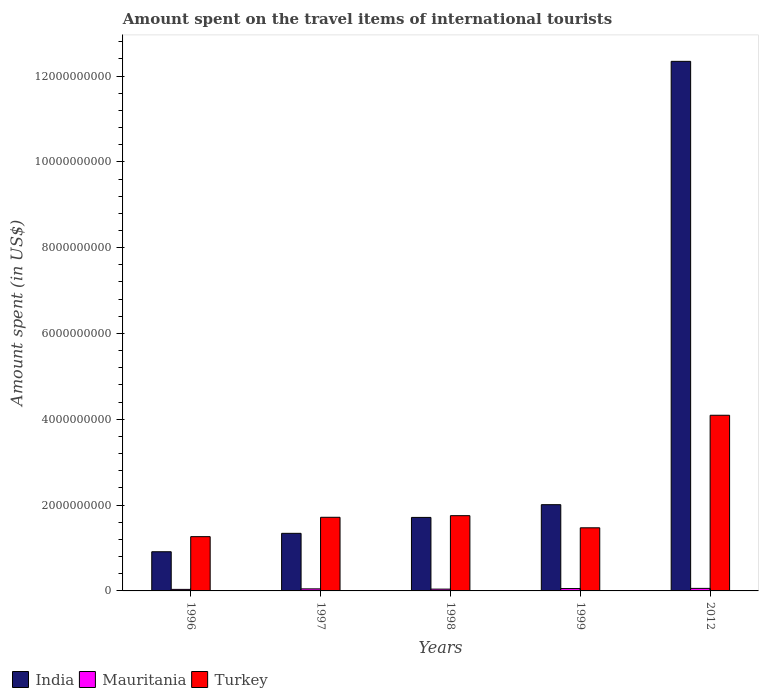How many different coloured bars are there?
Your answer should be compact. 3. Are the number of bars on each tick of the X-axis equal?
Ensure brevity in your answer.  Yes. How many bars are there on the 2nd tick from the right?
Provide a short and direct response. 3. What is the label of the 4th group of bars from the left?
Your answer should be very brief. 1999. What is the amount spent on the travel items of international tourists in India in 2012?
Offer a very short reply. 1.23e+1. Across all years, what is the maximum amount spent on the travel items of international tourists in Turkey?
Your answer should be very brief. 4.09e+09. Across all years, what is the minimum amount spent on the travel items of international tourists in India?
Make the answer very short. 9.13e+08. In which year was the amount spent on the travel items of international tourists in Turkey minimum?
Keep it short and to the point. 1996. What is the total amount spent on the travel items of international tourists in Mauritania in the graph?
Keep it short and to the point. 2.40e+08. What is the difference between the amount spent on the travel items of international tourists in Turkey in 1997 and that in 2012?
Offer a terse response. -2.38e+09. What is the difference between the amount spent on the travel items of international tourists in Mauritania in 2012 and the amount spent on the travel items of international tourists in India in 1999?
Provide a short and direct response. -1.95e+09. What is the average amount spent on the travel items of international tourists in Turkey per year?
Provide a short and direct response. 2.06e+09. In the year 1998, what is the difference between the amount spent on the travel items of international tourists in Mauritania and amount spent on the travel items of international tourists in Turkey?
Offer a very short reply. -1.71e+09. In how many years, is the amount spent on the travel items of international tourists in Turkey greater than 10800000000 US$?
Your answer should be compact. 0. What is the ratio of the amount spent on the travel items of international tourists in Mauritania in 1996 to that in 2012?
Provide a succinct answer. 0.61. What is the difference between the highest and the second highest amount spent on the travel items of international tourists in Turkey?
Keep it short and to the point. 2.34e+09. What is the difference between the highest and the lowest amount spent on the travel items of international tourists in India?
Your response must be concise. 1.14e+1. In how many years, is the amount spent on the travel items of international tourists in Mauritania greater than the average amount spent on the travel items of international tourists in Mauritania taken over all years?
Offer a terse response. 2. Is the sum of the amount spent on the travel items of international tourists in Mauritania in 1996 and 2012 greater than the maximum amount spent on the travel items of international tourists in India across all years?
Your answer should be very brief. No. What does the 2nd bar from the right in 1999 represents?
Ensure brevity in your answer.  Mauritania. How many bars are there?
Your answer should be very brief. 15. Are all the bars in the graph horizontal?
Make the answer very short. No. Are the values on the major ticks of Y-axis written in scientific E-notation?
Your answer should be very brief. No. Does the graph contain any zero values?
Your answer should be very brief. No. Where does the legend appear in the graph?
Provide a succinct answer. Bottom left. How many legend labels are there?
Your answer should be compact. 3. What is the title of the graph?
Your response must be concise. Amount spent on the travel items of international tourists. Does "Small states" appear as one of the legend labels in the graph?
Offer a terse response. No. What is the label or title of the Y-axis?
Your answer should be compact. Amount spent (in US$). What is the Amount spent (in US$) of India in 1996?
Give a very brief answer. 9.13e+08. What is the Amount spent (in US$) of Mauritania in 1996?
Provide a succinct answer. 3.60e+07. What is the Amount spent (in US$) in Turkey in 1996?
Give a very brief answer. 1.26e+09. What is the Amount spent (in US$) in India in 1997?
Make the answer very short. 1.34e+09. What is the Amount spent (in US$) of Mauritania in 1997?
Give a very brief answer. 4.80e+07. What is the Amount spent (in US$) of Turkey in 1997?
Keep it short and to the point. 1.72e+09. What is the Amount spent (in US$) in India in 1998?
Keep it short and to the point. 1.71e+09. What is the Amount spent (in US$) in Mauritania in 1998?
Your answer should be compact. 4.20e+07. What is the Amount spent (in US$) in Turkey in 1998?
Offer a terse response. 1.75e+09. What is the Amount spent (in US$) in India in 1999?
Offer a terse response. 2.01e+09. What is the Amount spent (in US$) of Mauritania in 1999?
Your answer should be very brief. 5.50e+07. What is the Amount spent (in US$) of Turkey in 1999?
Provide a succinct answer. 1.47e+09. What is the Amount spent (in US$) in India in 2012?
Make the answer very short. 1.23e+1. What is the Amount spent (in US$) in Mauritania in 2012?
Make the answer very short. 5.90e+07. What is the Amount spent (in US$) of Turkey in 2012?
Your answer should be very brief. 4.09e+09. Across all years, what is the maximum Amount spent (in US$) in India?
Your answer should be very brief. 1.23e+1. Across all years, what is the maximum Amount spent (in US$) of Mauritania?
Offer a terse response. 5.90e+07. Across all years, what is the maximum Amount spent (in US$) in Turkey?
Provide a succinct answer. 4.09e+09. Across all years, what is the minimum Amount spent (in US$) of India?
Make the answer very short. 9.13e+08. Across all years, what is the minimum Amount spent (in US$) in Mauritania?
Provide a short and direct response. 3.60e+07. Across all years, what is the minimum Amount spent (in US$) of Turkey?
Offer a very short reply. 1.26e+09. What is the total Amount spent (in US$) in India in the graph?
Your response must be concise. 1.83e+1. What is the total Amount spent (in US$) of Mauritania in the graph?
Your answer should be very brief. 2.40e+08. What is the total Amount spent (in US$) in Turkey in the graph?
Make the answer very short. 1.03e+1. What is the difference between the Amount spent (in US$) of India in 1996 and that in 1997?
Provide a short and direct response. -4.29e+08. What is the difference between the Amount spent (in US$) in Mauritania in 1996 and that in 1997?
Offer a terse response. -1.20e+07. What is the difference between the Amount spent (in US$) of Turkey in 1996 and that in 1997?
Provide a short and direct response. -4.51e+08. What is the difference between the Amount spent (in US$) of India in 1996 and that in 1998?
Keep it short and to the point. -8.00e+08. What is the difference between the Amount spent (in US$) in Mauritania in 1996 and that in 1998?
Give a very brief answer. -6.00e+06. What is the difference between the Amount spent (in US$) in Turkey in 1996 and that in 1998?
Give a very brief answer. -4.89e+08. What is the difference between the Amount spent (in US$) in India in 1996 and that in 1999?
Make the answer very short. -1.10e+09. What is the difference between the Amount spent (in US$) in Mauritania in 1996 and that in 1999?
Make the answer very short. -1.90e+07. What is the difference between the Amount spent (in US$) in Turkey in 1996 and that in 1999?
Give a very brief answer. -2.06e+08. What is the difference between the Amount spent (in US$) in India in 1996 and that in 2012?
Provide a succinct answer. -1.14e+1. What is the difference between the Amount spent (in US$) in Mauritania in 1996 and that in 2012?
Your response must be concise. -2.30e+07. What is the difference between the Amount spent (in US$) of Turkey in 1996 and that in 2012?
Make the answer very short. -2.83e+09. What is the difference between the Amount spent (in US$) in India in 1997 and that in 1998?
Your answer should be compact. -3.71e+08. What is the difference between the Amount spent (in US$) in Mauritania in 1997 and that in 1998?
Ensure brevity in your answer.  6.00e+06. What is the difference between the Amount spent (in US$) in Turkey in 1997 and that in 1998?
Provide a short and direct response. -3.80e+07. What is the difference between the Amount spent (in US$) of India in 1997 and that in 1999?
Offer a terse response. -6.68e+08. What is the difference between the Amount spent (in US$) of Mauritania in 1997 and that in 1999?
Provide a short and direct response. -7.00e+06. What is the difference between the Amount spent (in US$) in Turkey in 1997 and that in 1999?
Ensure brevity in your answer.  2.45e+08. What is the difference between the Amount spent (in US$) in India in 1997 and that in 2012?
Provide a succinct answer. -1.10e+1. What is the difference between the Amount spent (in US$) in Mauritania in 1997 and that in 2012?
Provide a succinct answer. -1.10e+07. What is the difference between the Amount spent (in US$) of Turkey in 1997 and that in 2012?
Your response must be concise. -2.38e+09. What is the difference between the Amount spent (in US$) of India in 1998 and that in 1999?
Ensure brevity in your answer.  -2.97e+08. What is the difference between the Amount spent (in US$) of Mauritania in 1998 and that in 1999?
Offer a terse response. -1.30e+07. What is the difference between the Amount spent (in US$) of Turkey in 1998 and that in 1999?
Ensure brevity in your answer.  2.83e+08. What is the difference between the Amount spent (in US$) of India in 1998 and that in 2012?
Keep it short and to the point. -1.06e+1. What is the difference between the Amount spent (in US$) of Mauritania in 1998 and that in 2012?
Give a very brief answer. -1.70e+07. What is the difference between the Amount spent (in US$) of Turkey in 1998 and that in 2012?
Ensure brevity in your answer.  -2.34e+09. What is the difference between the Amount spent (in US$) in India in 1999 and that in 2012?
Keep it short and to the point. -1.03e+1. What is the difference between the Amount spent (in US$) of Turkey in 1999 and that in 2012?
Offer a very short reply. -2.62e+09. What is the difference between the Amount spent (in US$) of India in 1996 and the Amount spent (in US$) of Mauritania in 1997?
Provide a succinct answer. 8.65e+08. What is the difference between the Amount spent (in US$) of India in 1996 and the Amount spent (in US$) of Turkey in 1997?
Provide a short and direct response. -8.03e+08. What is the difference between the Amount spent (in US$) of Mauritania in 1996 and the Amount spent (in US$) of Turkey in 1997?
Offer a terse response. -1.68e+09. What is the difference between the Amount spent (in US$) in India in 1996 and the Amount spent (in US$) in Mauritania in 1998?
Give a very brief answer. 8.71e+08. What is the difference between the Amount spent (in US$) in India in 1996 and the Amount spent (in US$) in Turkey in 1998?
Offer a terse response. -8.41e+08. What is the difference between the Amount spent (in US$) in Mauritania in 1996 and the Amount spent (in US$) in Turkey in 1998?
Keep it short and to the point. -1.72e+09. What is the difference between the Amount spent (in US$) of India in 1996 and the Amount spent (in US$) of Mauritania in 1999?
Give a very brief answer. 8.58e+08. What is the difference between the Amount spent (in US$) of India in 1996 and the Amount spent (in US$) of Turkey in 1999?
Give a very brief answer. -5.58e+08. What is the difference between the Amount spent (in US$) in Mauritania in 1996 and the Amount spent (in US$) in Turkey in 1999?
Ensure brevity in your answer.  -1.44e+09. What is the difference between the Amount spent (in US$) of India in 1996 and the Amount spent (in US$) of Mauritania in 2012?
Provide a succinct answer. 8.54e+08. What is the difference between the Amount spent (in US$) in India in 1996 and the Amount spent (in US$) in Turkey in 2012?
Your answer should be very brief. -3.18e+09. What is the difference between the Amount spent (in US$) in Mauritania in 1996 and the Amount spent (in US$) in Turkey in 2012?
Make the answer very short. -4.06e+09. What is the difference between the Amount spent (in US$) of India in 1997 and the Amount spent (in US$) of Mauritania in 1998?
Offer a very short reply. 1.30e+09. What is the difference between the Amount spent (in US$) of India in 1997 and the Amount spent (in US$) of Turkey in 1998?
Give a very brief answer. -4.12e+08. What is the difference between the Amount spent (in US$) in Mauritania in 1997 and the Amount spent (in US$) in Turkey in 1998?
Offer a terse response. -1.71e+09. What is the difference between the Amount spent (in US$) of India in 1997 and the Amount spent (in US$) of Mauritania in 1999?
Offer a terse response. 1.29e+09. What is the difference between the Amount spent (in US$) of India in 1997 and the Amount spent (in US$) of Turkey in 1999?
Your answer should be very brief. -1.29e+08. What is the difference between the Amount spent (in US$) of Mauritania in 1997 and the Amount spent (in US$) of Turkey in 1999?
Ensure brevity in your answer.  -1.42e+09. What is the difference between the Amount spent (in US$) of India in 1997 and the Amount spent (in US$) of Mauritania in 2012?
Give a very brief answer. 1.28e+09. What is the difference between the Amount spent (in US$) in India in 1997 and the Amount spent (in US$) in Turkey in 2012?
Offer a very short reply. -2.75e+09. What is the difference between the Amount spent (in US$) in Mauritania in 1997 and the Amount spent (in US$) in Turkey in 2012?
Your response must be concise. -4.05e+09. What is the difference between the Amount spent (in US$) of India in 1998 and the Amount spent (in US$) of Mauritania in 1999?
Your answer should be very brief. 1.66e+09. What is the difference between the Amount spent (in US$) in India in 1998 and the Amount spent (in US$) in Turkey in 1999?
Your answer should be compact. 2.42e+08. What is the difference between the Amount spent (in US$) of Mauritania in 1998 and the Amount spent (in US$) of Turkey in 1999?
Ensure brevity in your answer.  -1.43e+09. What is the difference between the Amount spent (in US$) in India in 1998 and the Amount spent (in US$) in Mauritania in 2012?
Keep it short and to the point. 1.65e+09. What is the difference between the Amount spent (in US$) in India in 1998 and the Amount spent (in US$) in Turkey in 2012?
Your answer should be very brief. -2.38e+09. What is the difference between the Amount spent (in US$) of Mauritania in 1998 and the Amount spent (in US$) of Turkey in 2012?
Provide a succinct answer. -4.05e+09. What is the difference between the Amount spent (in US$) of India in 1999 and the Amount spent (in US$) of Mauritania in 2012?
Your answer should be compact. 1.95e+09. What is the difference between the Amount spent (in US$) in India in 1999 and the Amount spent (in US$) in Turkey in 2012?
Your answer should be very brief. -2.08e+09. What is the difference between the Amount spent (in US$) of Mauritania in 1999 and the Amount spent (in US$) of Turkey in 2012?
Your answer should be very brief. -4.04e+09. What is the average Amount spent (in US$) in India per year?
Your response must be concise. 3.66e+09. What is the average Amount spent (in US$) of Mauritania per year?
Offer a terse response. 4.80e+07. What is the average Amount spent (in US$) in Turkey per year?
Provide a succinct answer. 2.06e+09. In the year 1996, what is the difference between the Amount spent (in US$) of India and Amount spent (in US$) of Mauritania?
Provide a succinct answer. 8.77e+08. In the year 1996, what is the difference between the Amount spent (in US$) in India and Amount spent (in US$) in Turkey?
Make the answer very short. -3.52e+08. In the year 1996, what is the difference between the Amount spent (in US$) in Mauritania and Amount spent (in US$) in Turkey?
Your answer should be compact. -1.23e+09. In the year 1997, what is the difference between the Amount spent (in US$) in India and Amount spent (in US$) in Mauritania?
Your answer should be very brief. 1.29e+09. In the year 1997, what is the difference between the Amount spent (in US$) in India and Amount spent (in US$) in Turkey?
Give a very brief answer. -3.74e+08. In the year 1997, what is the difference between the Amount spent (in US$) in Mauritania and Amount spent (in US$) in Turkey?
Give a very brief answer. -1.67e+09. In the year 1998, what is the difference between the Amount spent (in US$) in India and Amount spent (in US$) in Mauritania?
Keep it short and to the point. 1.67e+09. In the year 1998, what is the difference between the Amount spent (in US$) in India and Amount spent (in US$) in Turkey?
Keep it short and to the point. -4.10e+07. In the year 1998, what is the difference between the Amount spent (in US$) of Mauritania and Amount spent (in US$) of Turkey?
Ensure brevity in your answer.  -1.71e+09. In the year 1999, what is the difference between the Amount spent (in US$) of India and Amount spent (in US$) of Mauritania?
Provide a succinct answer. 1.96e+09. In the year 1999, what is the difference between the Amount spent (in US$) of India and Amount spent (in US$) of Turkey?
Offer a terse response. 5.39e+08. In the year 1999, what is the difference between the Amount spent (in US$) of Mauritania and Amount spent (in US$) of Turkey?
Provide a short and direct response. -1.42e+09. In the year 2012, what is the difference between the Amount spent (in US$) in India and Amount spent (in US$) in Mauritania?
Offer a terse response. 1.23e+1. In the year 2012, what is the difference between the Amount spent (in US$) of India and Amount spent (in US$) of Turkey?
Your answer should be very brief. 8.25e+09. In the year 2012, what is the difference between the Amount spent (in US$) in Mauritania and Amount spent (in US$) in Turkey?
Offer a very short reply. -4.04e+09. What is the ratio of the Amount spent (in US$) of India in 1996 to that in 1997?
Offer a terse response. 0.68. What is the ratio of the Amount spent (in US$) of Mauritania in 1996 to that in 1997?
Give a very brief answer. 0.75. What is the ratio of the Amount spent (in US$) of Turkey in 1996 to that in 1997?
Give a very brief answer. 0.74. What is the ratio of the Amount spent (in US$) of India in 1996 to that in 1998?
Provide a succinct answer. 0.53. What is the ratio of the Amount spent (in US$) of Mauritania in 1996 to that in 1998?
Your answer should be very brief. 0.86. What is the ratio of the Amount spent (in US$) in Turkey in 1996 to that in 1998?
Keep it short and to the point. 0.72. What is the ratio of the Amount spent (in US$) of India in 1996 to that in 1999?
Your answer should be very brief. 0.45. What is the ratio of the Amount spent (in US$) in Mauritania in 1996 to that in 1999?
Ensure brevity in your answer.  0.65. What is the ratio of the Amount spent (in US$) of Turkey in 1996 to that in 1999?
Ensure brevity in your answer.  0.86. What is the ratio of the Amount spent (in US$) in India in 1996 to that in 2012?
Your answer should be very brief. 0.07. What is the ratio of the Amount spent (in US$) in Mauritania in 1996 to that in 2012?
Provide a short and direct response. 0.61. What is the ratio of the Amount spent (in US$) in Turkey in 1996 to that in 2012?
Give a very brief answer. 0.31. What is the ratio of the Amount spent (in US$) in India in 1997 to that in 1998?
Your answer should be very brief. 0.78. What is the ratio of the Amount spent (in US$) of Mauritania in 1997 to that in 1998?
Offer a terse response. 1.14. What is the ratio of the Amount spent (in US$) in Turkey in 1997 to that in 1998?
Your response must be concise. 0.98. What is the ratio of the Amount spent (in US$) of India in 1997 to that in 1999?
Give a very brief answer. 0.67. What is the ratio of the Amount spent (in US$) of Mauritania in 1997 to that in 1999?
Offer a very short reply. 0.87. What is the ratio of the Amount spent (in US$) in Turkey in 1997 to that in 1999?
Ensure brevity in your answer.  1.17. What is the ratio of the Amount spent (in US$) in India in 1997 to that in 2012?
Your answer should be very brief. 0.11. What is the ratio of the Amount spent (in US$) in Mauritania in 1997 to that in 2012?
Provide a succinct answer. 0.81. What is the ratio of the Amount spent (in US$) in Turkey in 1997 to that in 2012?
Offer a terse response. 0.42. What is the ratio of the Amount spent (in US$) in India in 1998 to that in 1999?
Make the answer very short. 0.85. What is the ratio of the Amount spent (in US$) in Mauritania in 1998 to that in 1999?
Offer a terse response. 0.76. What is the ratio of the Amount spent (in US$) in Turkey in 1998 to that in 1999?
Offer a very short reply. 1.19. What is the ratio of the Amount spent (in US$) of India in 1998 to that in 2012?
Your response must be concise. 0.14. What is the ratio of the Amount spent (in US$) of Mauritania in 1998 to that in 2012?
Provide a succinct answer. 0.71. What is the ratio of the Amount spent (in US$) of Turkey in 1998 to that in 2012?
Give a very brief answer. 0.43. What is the ratio of the Amount spent (in US$) in India in 1999 to that in 2012?
Ensure brevity in your answer.  0.16. What is the ratio of the Amount spent (in US$) in Mauritania in 1999 to that in 2012?
Give a very brief answer. 0.93. What is the ratio of the Amount spent (in US$) in Turkey in 1999 to that in 2012?
Keep it short and to the point. 0.36. What is the difference between the highest and the second highest Amount spent (in US$) of India?
Provide a short and direct response. 1.03e+1. What is the difference between the highest and the second highest Amount spent (in US$) in Mauritania?
Make the answer very short. 4.00e+06. What is the difference between the highest and the second highest Amount spent (in US$) in Turkey?
Provide a short and direct response. 2.34e+09. What is the difference between the highest and the lowest Amount spent (in US$) in India?
Give a very brief answer. 1.14e+1. What is the difference between the highest and the lowest Amount spent (in US$) of Mauritania?
Provide a succinct answer. 2.30e+07. What is the difference between the highest and the lowest Amount spent (in US$) of Turkey?
Provide a short and direct response. 2.83e+09. 